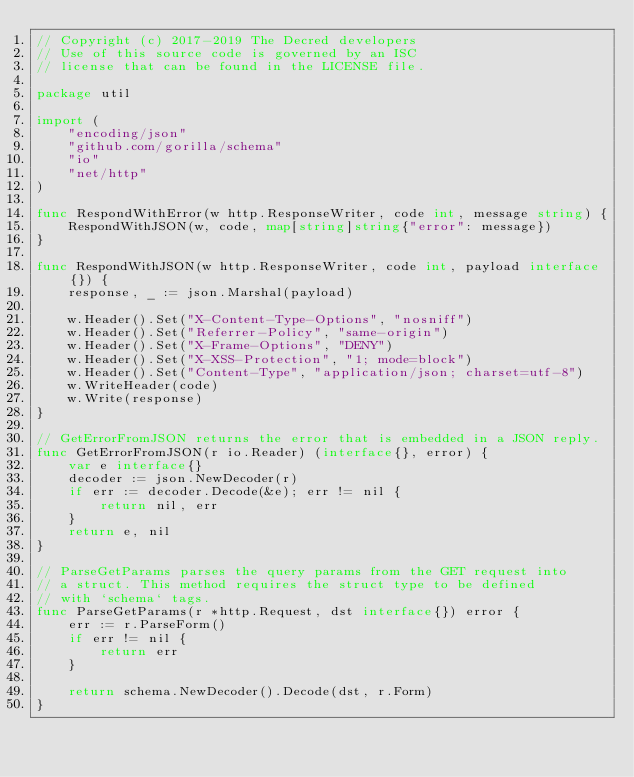<code> <loc_0><loc_0><loc_500><loc_500><_Go_>// Copyright (c) 2017-2019 The Decred developers
// Use of this source code is governed by an ISC
// license that can be found in the LICENSE file.

package util

import (
	"encoding/json"
	"github.com/gorilla/schema"
	"io"
	"net/http"
)

func RespondWithError(w http.ResponseWriter, code int, message string) {
	RespondWithJSON(w, code, map[string]string{"error": message})
}

func RespondWithJSON(w http.ResponseWriter, code int, payload interface{}) {
	response, _ := json.Marshal(payload)

	w.Header().Set("X-Content-Type-Options", "nosniff")
	w.Header().Set("Referrer-Policy", "same-origin")
	w.Header().Set("X-Frame-Options", "DENY")
	w.Header().Set("X-XSS-Protection", "1; mode=block")
	w.Header().Set("Content-Type", "application/json; charset=utf-8")
	w.WriteHeader(code)
	w.Write(response)
}

// GetErrorFromJSON returns the error that is embedded in a JSON reply.
func GetErrorFromJSON(r io.Reader) (interface{}, error) {
	var e interface{}
	decoder := json.NewDecoder(r)
	if err := decoder.Decode(&e); err != nil {
		return nil, err
	}
	return e, nil
}

// ParseGetParams parses the query params from the GET request into
// a struct. This method requires the struct type to be defined
// with `schema` tags.
func ParseGetParams(r *http.Request, dst interface{}) error {
	err := r.ParseForm()
	if err != nil {
		return err
	}

	return schema.NewDecoder().Decode(dst, r.Form)
}
</code> 